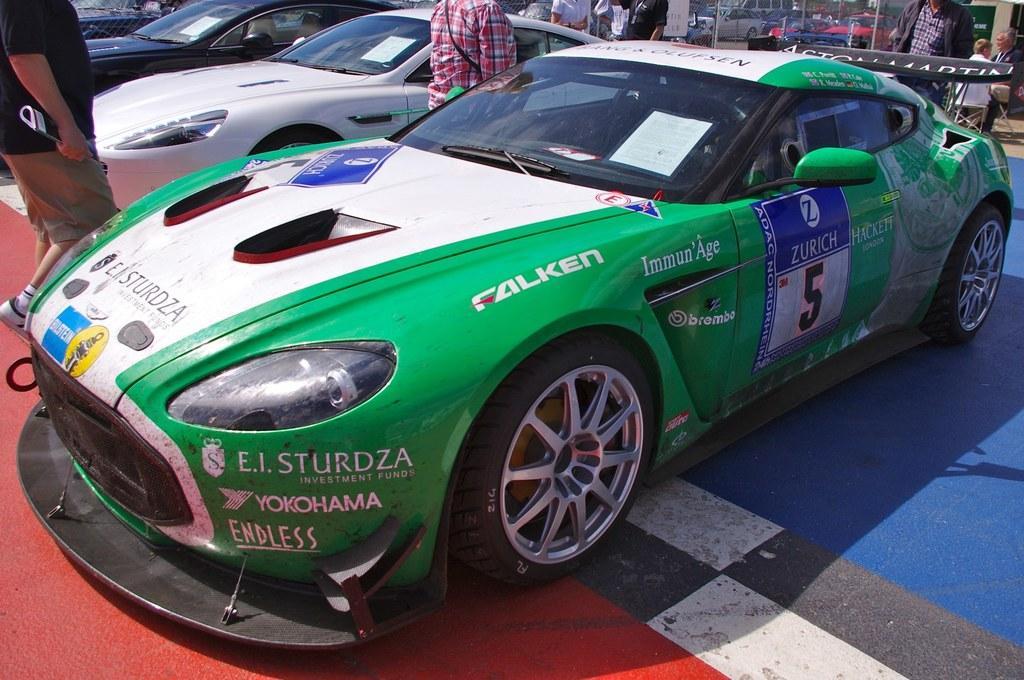Describe this image in one or two sentences. In this image in front there are few cars. Beside the cars there are few people standing on the road. In the background there are two people sitting on the chairs. 